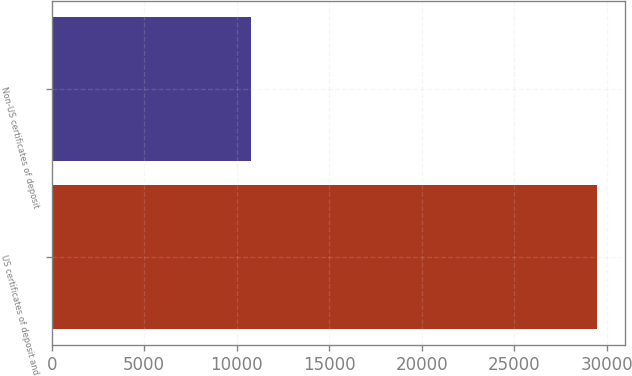<chart> <loc_0><loc_0><loc_500><loc_500><bar_chart><fcel>US certificates of deposit and<fcel>Non-US certificates of deposit<nl><fcel>29505<fcel>10792<nl></chart> 